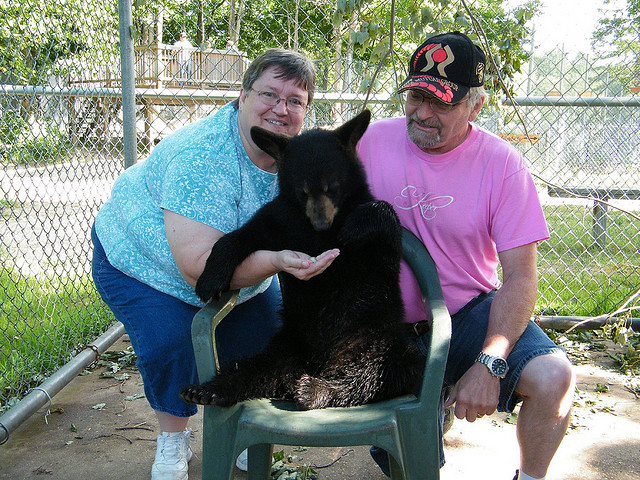<image>Can this bear survive in the wild on its own without its mother? I don't know if this bear can survive in the wild on its own without its mother. Can this bear survive in the wild on its own without its mother? I am not sure if this bear can survive in the wild on its own without its mother. However, it can be both yes or no. 